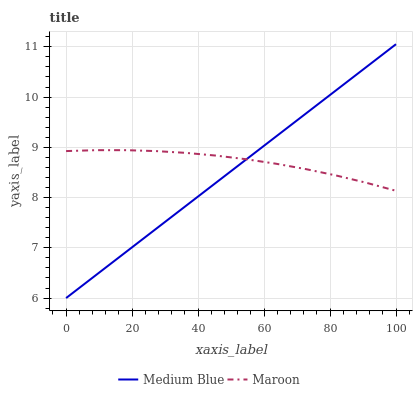Does Medium Blue have the minimum area under the curve?
Answer yes or no. Yes. Does Maroon have the maximum area under the curve?
Answer yes or no. Yes. Does Maroon have the minimum area under the curve?
Answer yes or no. No. Is Medium Blue the smoothest?
Answer yes or no. Yes. Is Maroon the roughest?
Answer yes or no. Yes. Is Maroon the smoothest?
Answer yes or no. No. Does Medium Blue have the lowest value?
Answer yes or no. Yes. Does Maroon have the lowest value?
Answer yes or no. No. Does Medium Blue have the highest value?
Answer yes or no. Yes. Does Maroon have the highest value?
Answer yes or no. No. Does Maroon intersect Medium Blue?
Answer yes or no. Yes. Is Maroon less than Medium Blue?
Answer yes or no. No. Is Maroon greater than Medium Blue?
Answer yes or no. No. 